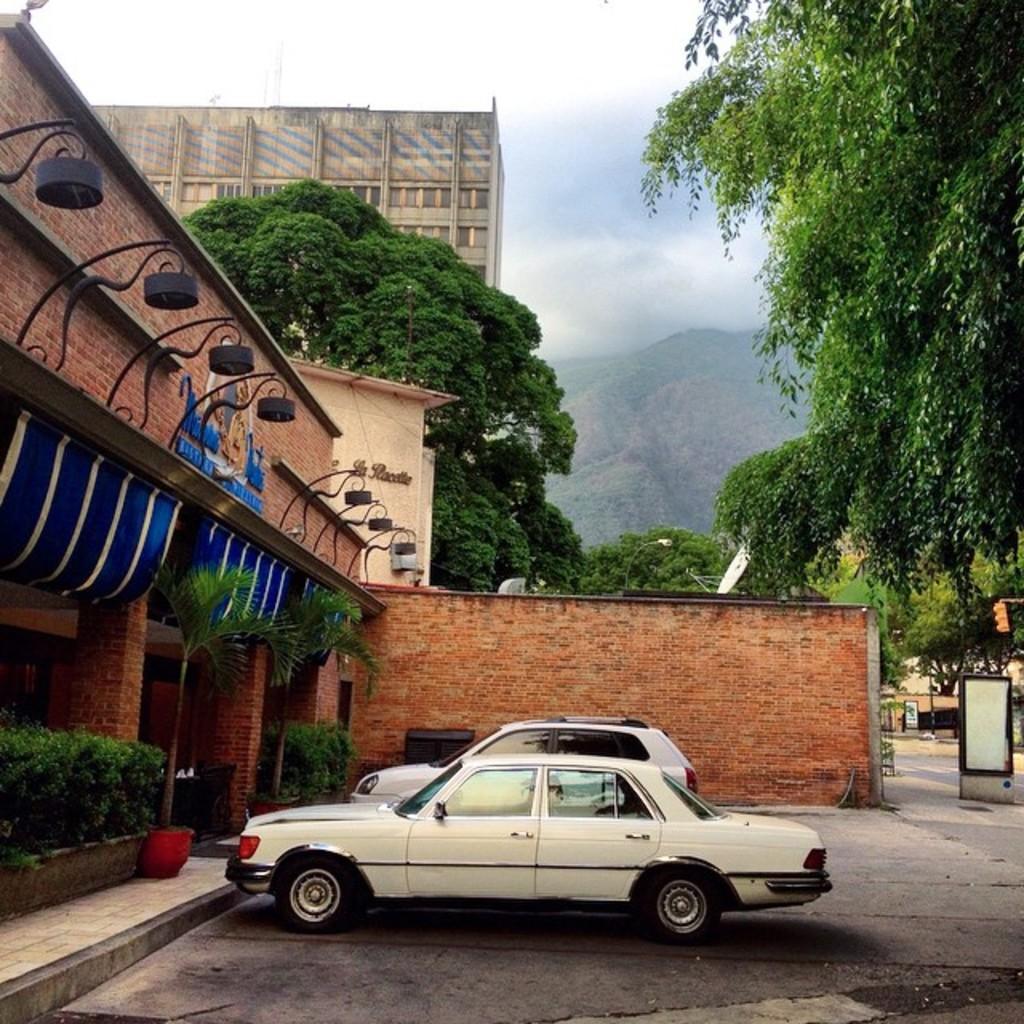Can you describe this image briefly? In this image I can see flower pot , plants and bushes and there are two vehicles parking in front of the building and at the top I can see the sky ,trees and hills and building 